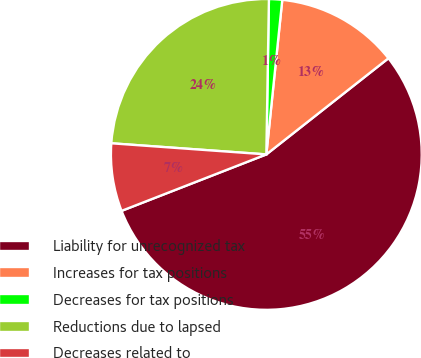Convert chart. <chart><loc_0><loc_0><loc_500><loc_500><pie_chart><fcel>Liability for unrecognized tax<fcel>Increases for tax positions<fcel>Decreases for tax positions<fcel>Reductions due to lapsed<fcel>Decreases related to<nl><fcel>54.71%<fcel>12.75%<fcel>1.37%<fcel>24.13%<fcel>7.06%<nl></chart> 